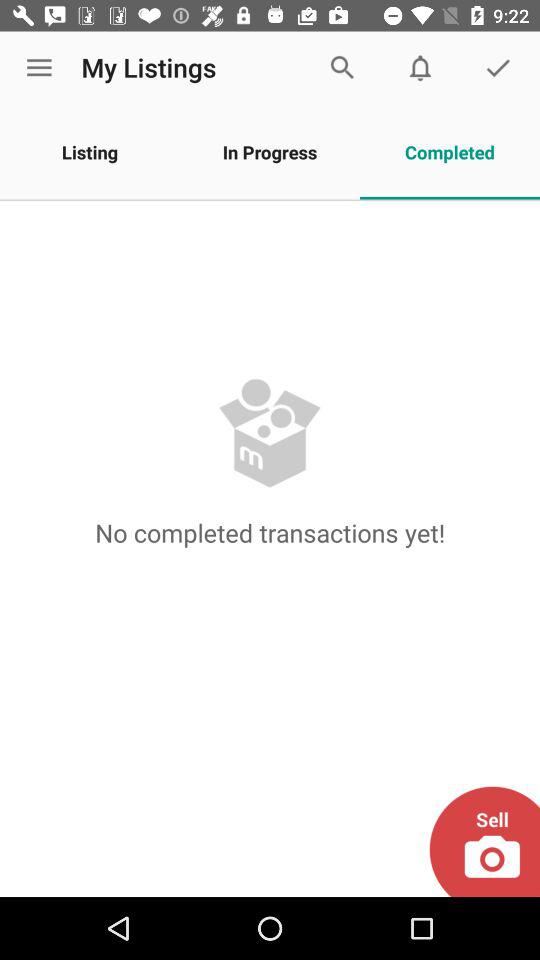How many transactions have been completed?
When the provided information is insufficient, respond with <no answer>. <no answer> 